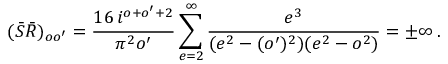<formula> <loc_0><loc_0><loc_500><loc_500>( \bar { S } \bar { R } ) _ { o o ^ { \prime } } = { \frac { 1 6 \, i ^ { o + o ^ { \prime } + 2 } } { \pi ^ { 2 } o ^ { \prime } } } \sum _ { e = 2 } ^ { \infty } { \frac { e ^ { 3 } } { ( e ^ { 2 } - ( o ^ { \prime } ) ^ { 2 } ) ( e ^ { 2 } - o ^ { 2 } ) } } = \pm \infty \, .</formula> 